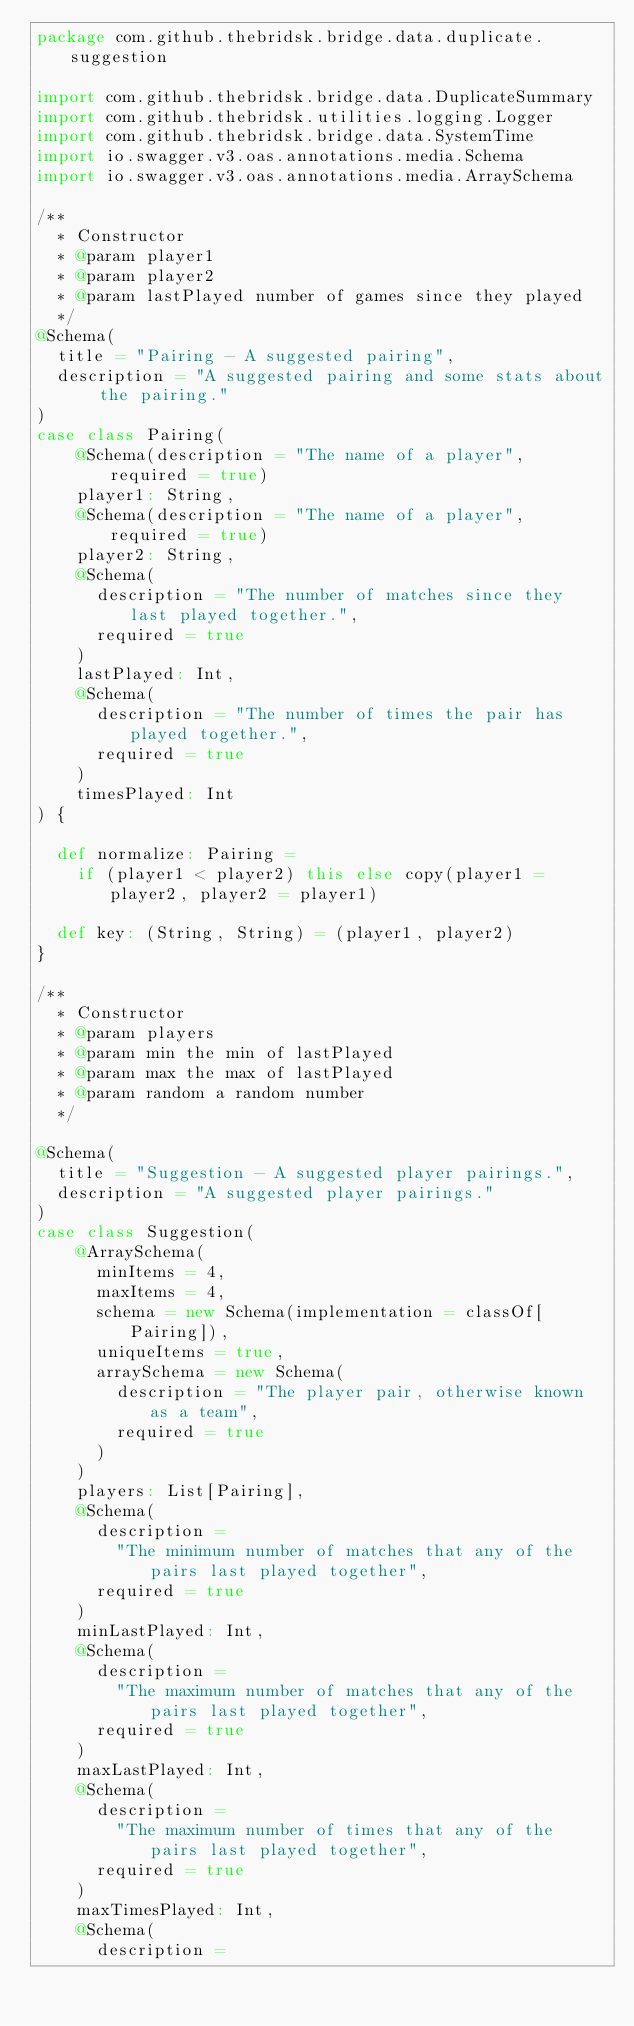Convert code to text. <code><loc_0><loc_0><loc_500><loc_500><_Scala_>package com.github.thebridsk.bridge.data.duplicate.suggestion

import com.github.thebridsk.bridge.data.DuplicateSummary
import com.github.thebridsk.utilities.logging.Logger
import com.github.thebridsk.bridge.data.SystemTime
import io.swagger.v3.oas.annotations.media.Schema
import io.swagger.v3.oas.annotations.media.ArraySchema

/**
  * Constructor
  * @param player1
  * @param player2
  * @param lastPlayed number of games since they played
  */
@Schema(
  title = "Pairing - A suggested pairing",
  description = "A suggested pairing and some stats about the pairing."
)
case class Pairing(
    @Schema(description = "The name of a player", required = true)
    player1: String,
    @Schema(description = "The name of a player", required = true)
    player2: String,
    @Schema(
      description = "The number of matches since they last played together.",
      required = true
    )
    lastPlayed: Int,
    @Schema(
      description = "The number of times the pair has played together.",
      required = true
    )
    timesPlayed: Int
) {

  def normalize: Pairing =
    if (player1 < player2) this else copy(player1 = player2, player2 = player1)

  def key: (String, String) = (player1, player2)
}

/**
  * Constructor
  * @param players
  * @param min the min of lastPlayed
  * @param max the max of lastPlayed
  * @param random a random number
  */

@Schema(
  title = "Suggestion - A suggested player pairings.",
  description = "A suggested player pairings."
)
case class Suggestion(
    @ArraySchema(
      minItems = 4,
      maxItems = 4,
      schema = new Schema(implementation = classOf[Pairing]),
      uniqueItems = true,
      arraySchema = new Schema(
        description = "The player pair, otherwise known as a team",
        required = true
      )
    )
    players: List[Pairing],
    @Schema(
      description =
        "The minimum number of matches that any of the pairs last played together",
      required = true
    )
    minLastPlayed: Int,
    @Schema(
      description =
        "The maximum number of matches that any of the pairs last played together",
      required = true
    )
    maxLastPlayed: Int,
    @Schema(
      description =
        "The maximum number of times that any of the pairs last played together",
      required = true
    )
    maxTimesPlayed: Int,
    @Schema(
      description =</code> 